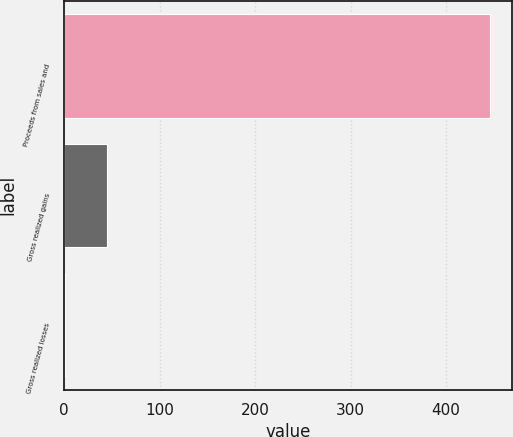Convert chart. <chart><loc_0><loc_0><loc_500><loc_500><bar_chart><fcel>Proceeds from sales and<fcel>Gross realized gains<fcel>Gross realized losses<nl><fcel>446.4<fcel>45<fcel>0.4<nl></chart> 